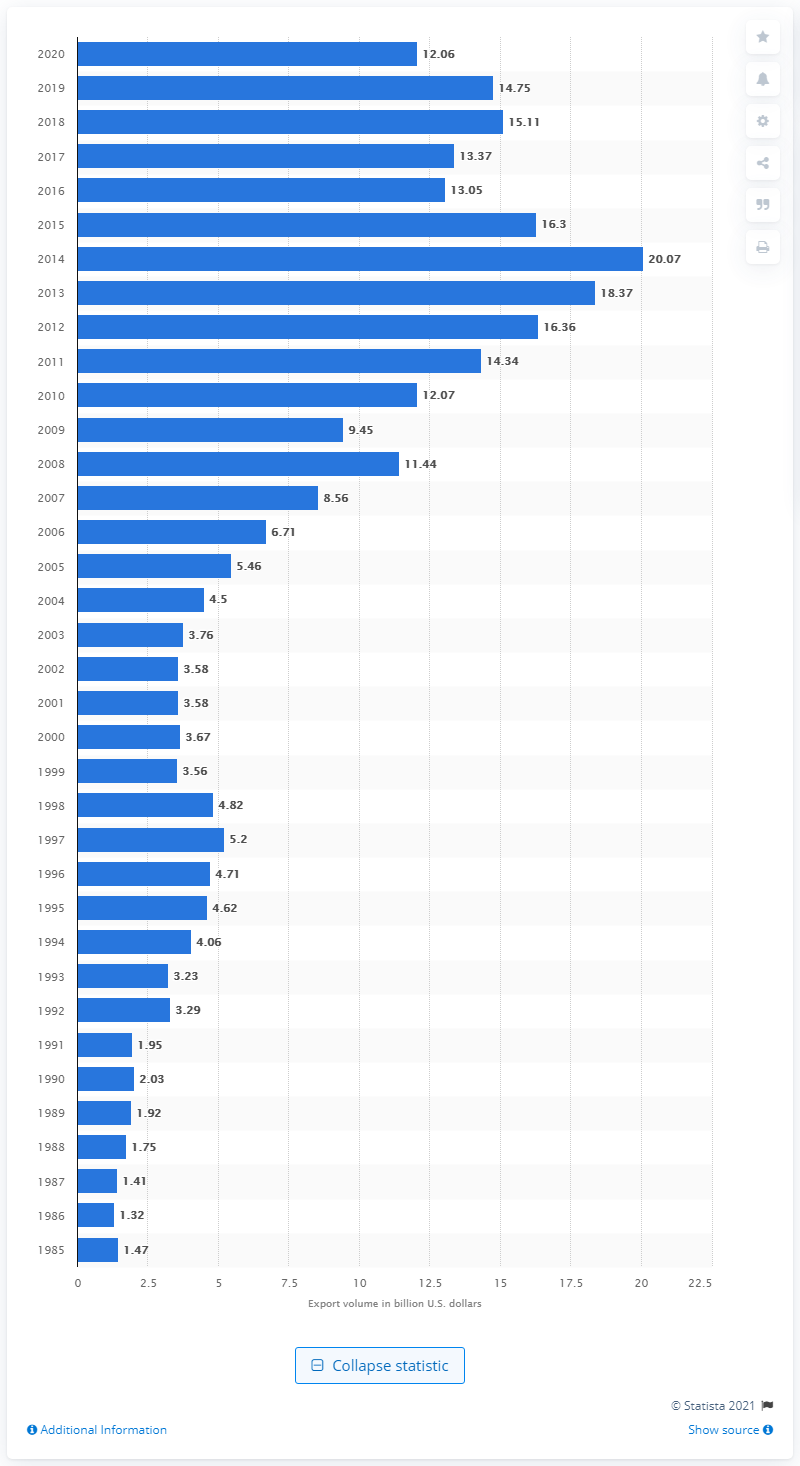What year saw the highest volume of exports from the U.S. to Colombia, according to the chart? According to the chart, the year 2013 saw the highest volume of exports from the U.S. to Colombia, with the value reaching approximately 20 billion dollars. 